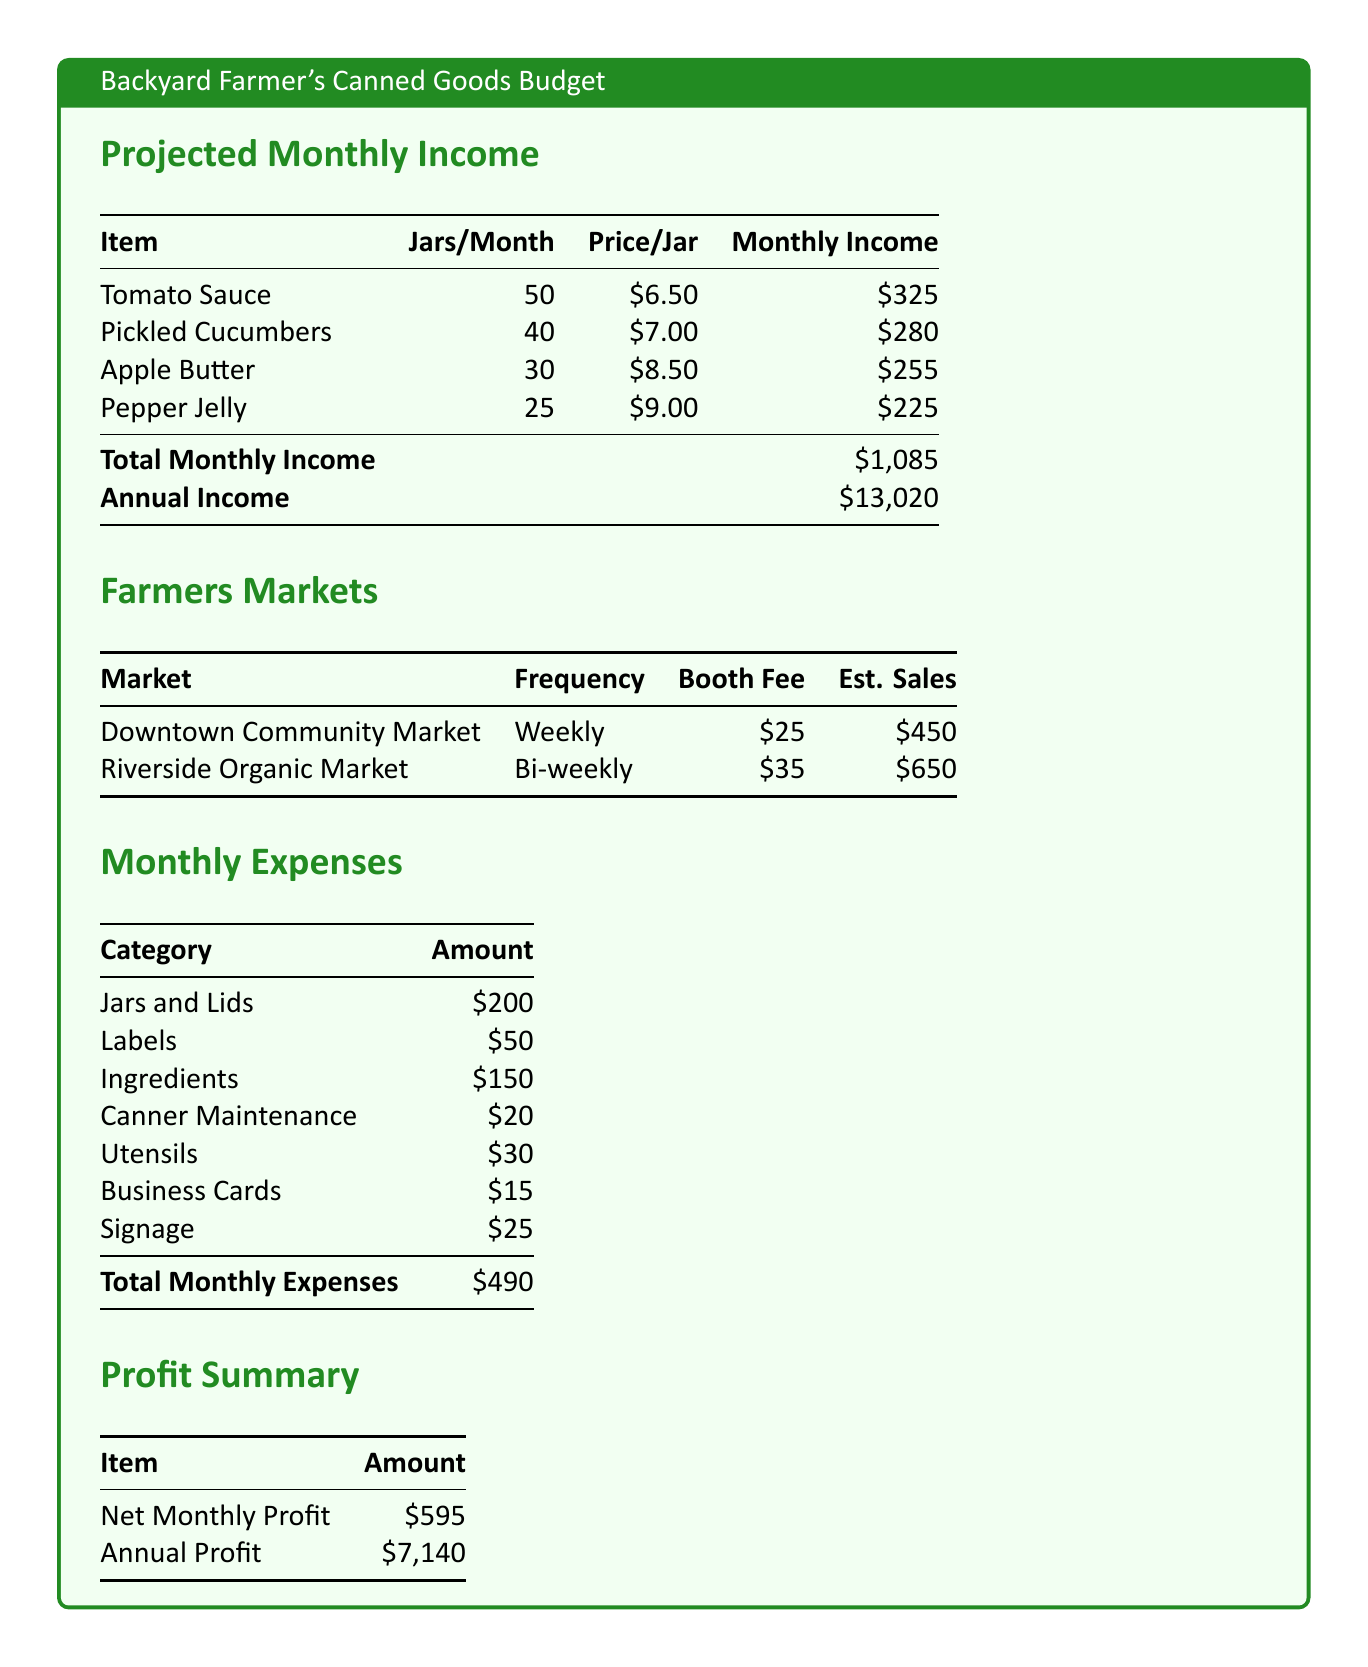What is the total monthly income? The total monthly income is calculated by summing the income from each canned good, which totals to $1,085.
Answer: $1,085 How many jars of pickled cucumbers are expected to be sold? The document specifies that 40 jars of pickled cucumbers are projected to be sold every month.
Answer: 40 What is the price per jar of apple butter? The price per jar of apple butter is stated as $8.50 in the budget.
Answer: $8.50 What is the estimated sales income from the Downtown Community Market? The estimated sales income from the Downtown Community Market is $450 as indicated in the farmers markets section.
Answer: $450 What is the total monthly expense? The total monthly expense is calculated by adding all itemized expenses, which equals $490.
Answer: $490 What is the net monthly profit? The net monthly profit is shown as the amount remaining after expenses, which is $595.
Answer: $595 How much is the booth fee for the Riverside Organic Market? The booth fee for the Riverside Organic Market is provided as $35 in the document.
Answer: $35 What is the annual profit projected from selling canned goods? The annual profit is derived from the net monthly profit, totaling $7,140 as per the budget.
Answer: $7,140 What is the charge for labels monthly? The amount allocated for labels is mentioned as $50 in the monthly expenses section.
Answer: $50 